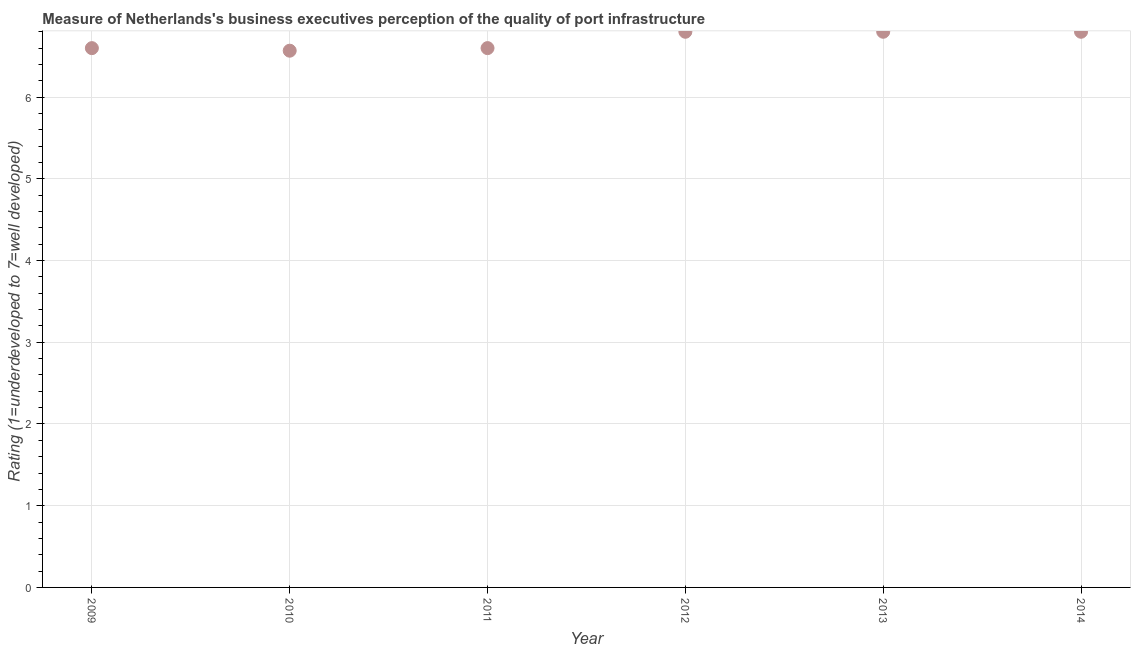What is the rating measuring quality of port infrastructure in 2009?
Ensure brevity in your answer.  6.6. Across all years, what is the minimum rating measuring quality of port infrastructure?
Offer a terse response. 6.57. In which year was the rating measuring quality of port infrastructure maximum?
Make the answer very short. 2012. What is the sum of the rating measuring quality of port infrastructure?
Your response must be concise. 40.17. What is the difference between the rating measuring quality of port infrastructure in 2010 and 2014?
Your answer should be compact. -0.23. What is the average rating measuring quality of port infrastructure per year?
Your response must be concise. 6.69. What is the median rating measuring quality of port infrastructure?
Make the answer very short. 6.7. Is the rating measuring quality of port infrastructure in 2011 less than that in 2012?
Keep it short and to the point. Yes. Is the difference between the rating measuring quality of port infrastructure in 2011 and 2013 greater than the difference between any two years?
Give a very brief answer. No. Is the sum of the rating measuring quality of port infrastructure in 2009 and 2010 greater than the maximum rating measuring quality of port infrastructure across all years?
Provide a succinct answer. Yes. What is the difference between the highest and the lowest rating measuring quality of port infrastructure?
Your response must be concise. 0.23. In how many years, is the rating measuring quality of port infrastructure greater than the average rating measuring quality of port infrastructure taken over all years?
Your answer should be very brief. 3. How many dotlines are there?
Offer a very short reply. 1. What is the difference between two consecutive major ticks on the Y-axis?
Give a very brief answer. 1. Does the graph contain any zero values?
Offer a very short reply. No. Does the graph contain grids?
Offer a very short reply. Yes. What is the title of the graph?
Give a very brief answer. Measure of Netherlands's business executives perception of the quality of port infrastructure. What is the label or title of the X-axis?
Give a very brief answer. Year. What is the label or title of the Y-axis?
Ensure brevity in your answer.  Rating (1=underdeveloped to 7=well developed) . What is the Rating (1=underdeveloped to 7=well developed)  in 2009?
Offer a very short reply. 6.6. What is the Rating (1=underdeveloped to 7=well developed)  in 2010?
Your answer should be very brief. 6.57. What is the Rating (1=underdeveloped to 7=well developed)  in 2011?
Ensure brevity in your answer.  6.6. What is the Rating (1=underdeveloped to 7=well developed)  in 2012?
Your response must be concise. 6.8. What is the Rating (1=underdeveloped to 7=well developed)  in 2013?
Ensure brevity in your answer.  6.8. What is the difference between the Rating (1=underdeveloped to 7=well developed)  in 2009 and 2010?
Provide a short and direct response. 0.03. What is the difference between the Rating (1=underdeveloped to 7=well developed)  in 2009 and 2011?
Your answer should be very brief. -0. What is the difference between the Rating (1=underdeveloped to 7=well developed)  in 2009 and 2012?
Provide a short and direct response. -0.2. What is the difference between the Rating (1=underdeveloped to 7=well developed)  in 2009 and 2013?
Your answer should be very brief. -0.2. What is the difference between the Rating (1=underdeveloped to 7=well developed)  in 2009 and 2014?
Keep it short and to the point. -0.2. What is the difference between the Rating (1=underdeveloped to 7=well developed)  in 2010 and 2011?
Your answer should be very brief. -0.03. What is the difference between the Rating (1=underdeveloped to 7=well developed)  in 2010 and 2012?
Your response must be concise. -0.23. What is the difference between the Rating (1=underdeveloped to 7=well developed)  in 2010 and 2013?
Keep it short and to the point. -0.23. What is the difference between the Rating (1=underdeveloped to 7=well developed)  in 2010 and 2014?
Make the answer very short. -0.23. What is the difference between the Rating (1=underdeveloped to 7=well developed)  in 2011 and 2014?
Ensure brevity in your answer.  -0.2. What is the difference between the Rating (1=underdeveloped to 7=well developed)  in 2013 and 2014?
Keep it short and to the point. 0. What is the ratio of the Rating (1=underdeveloped to 7=well developed)  in 2009 to that in 2012?
Provide a short and direct response. 0.97. What is the ratio of the Rating (1=underdeveloped to 7=well developed)  in 2011 to that in 2013?
Provide a short and direct response. 0.97. What is the ratio of the Rating (1=underdeveloped to 7=well developed)  in 2011 to that in 2014?
Make the answer very short. 0.97. What is the ratio of the Rating (1=underdeveloped to 7=well developed)  in 2012 to that in 2014?
Your answer should be compact. 1. What is the ratio of the Rating (1=underdeveloped to 7=well developed)  in 2013 to that in 2014?
Keep it short and to the point. 1. 